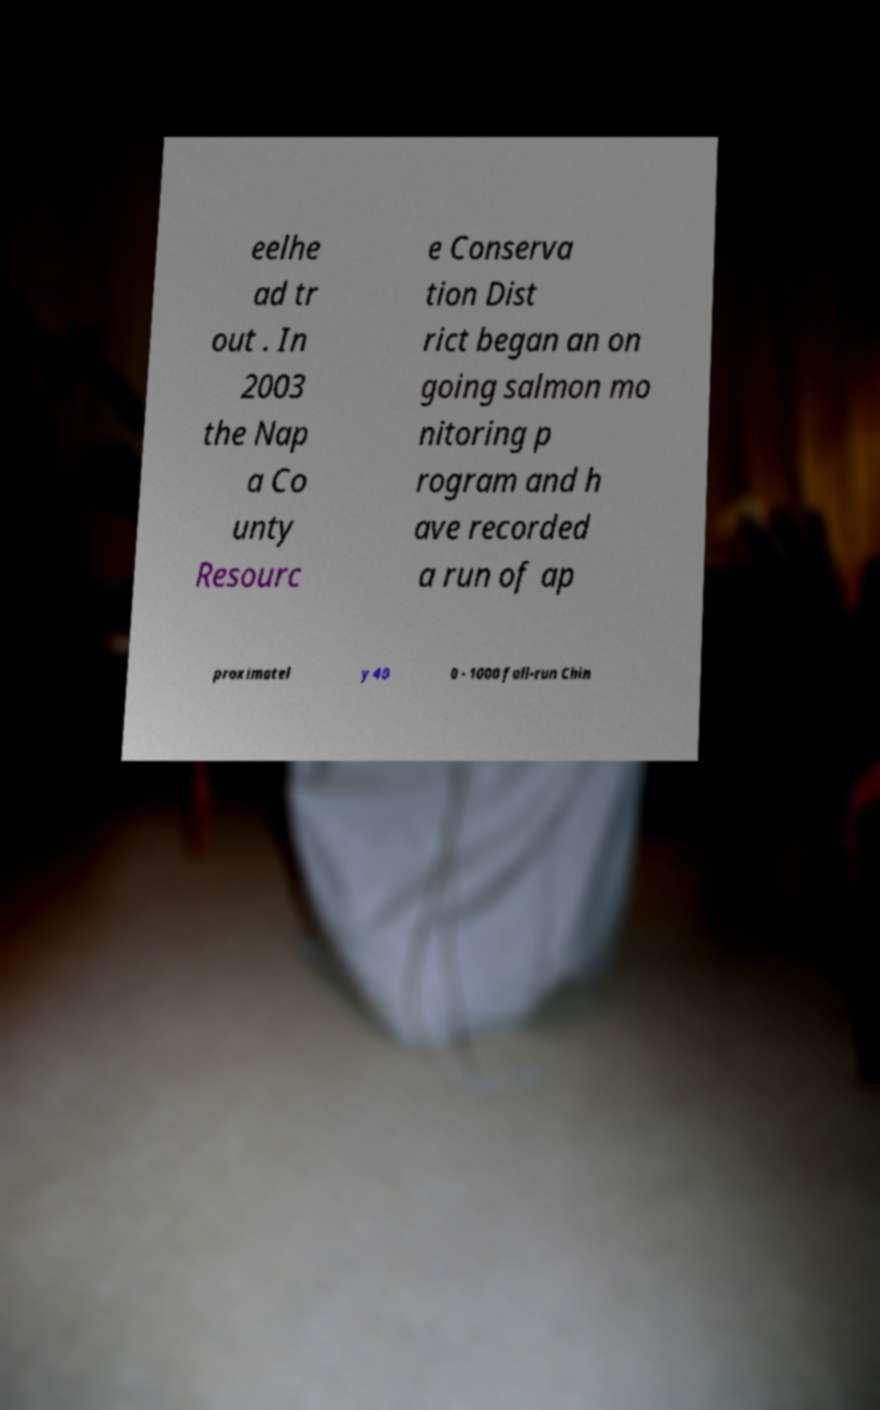Could you assist in decoding the text presented in this image and type it out clearly? eelhe ad tr out . In 2003 the Nap a Co unty Resourc e Conserva tion Dist rict began an on going salmon mo nitoring p rogram and h ave recorded a run of ap proximatel y 40 0 - 1000 fall-run Chin 